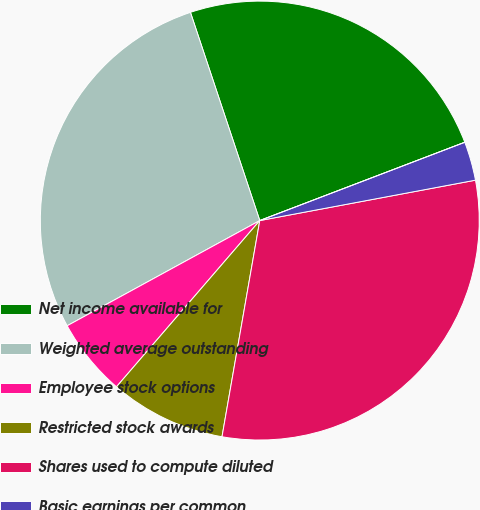Convert chart. <chart><loc_0><loc_0><loc_500><loc_500><pie_chart><fcel>Net income available for<fcel>Weighted average outstanding<fcel>Employee stock options<fcel>Restricted stock awards<fcel>Shares used to compute diluted<fcel>Basic earnings per common<fcel>Diluted earnings per common<nl><fcel>24.31%<fcel>27.84%<fcel>5.72%<fcel>8.57%<fcel>30.7%<fcel>2.86%<fcel>0.0%<nl></chart> 